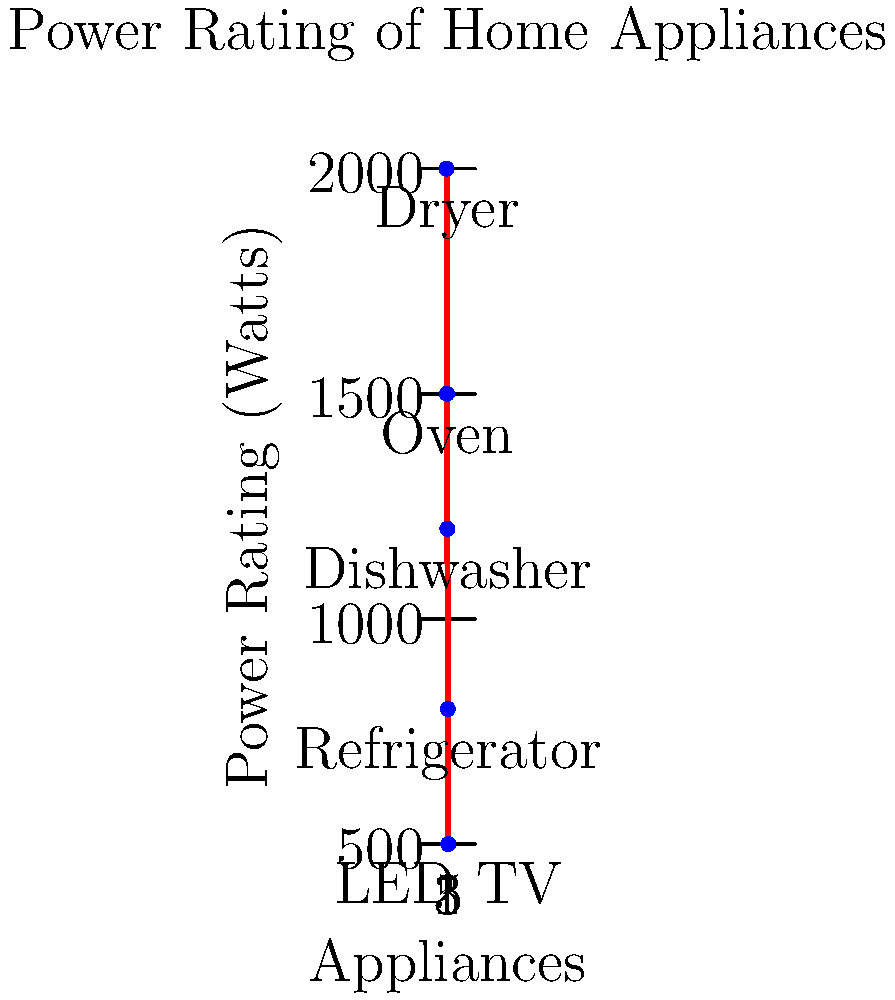As a researcher studying sustainable design, you're analyzing the power consumption of various home appliances. Using the power rating chart provided, calculate the difference in daily energy consumption between a dryer used for 1 hour and an LED TV used for 5 hours. Assume a constant power draw for each appliance during operation. Express your answer in kilowatt-hours (kWh). To solve this problem, we'll follow these steps:

1. Identify the power ratings from the chart:
   Dryer: 2000 W
   LED TV: 500 W

2. Calculate the energy consumption for each appliance:
   Energy (kWh) = Power (kW) × Time (hours)

   For the dryer:
   $E_{dryer} = 2.0 \text{ kW} \times 1 \text{ hour} = 2.0 \text{ kWh}$

   For the LED TV:
   $E_{TV} = 0.5 \text{ kW} \times 5 \text{ hours} = 2.5 \text{ kWh}$

3. Calculate the difference in energy consumption:
   $\Delta E = E_{dryer} - E_{TV} = 2.0 \text{ kWh} - 2.5 \text{ kWh} = -0.5 \text{ kWh}$

The negative value indicates that the LED TV consumes 0.5 kWh more energy than the dryer in this scenario.
Answer: -0.5 kWh 